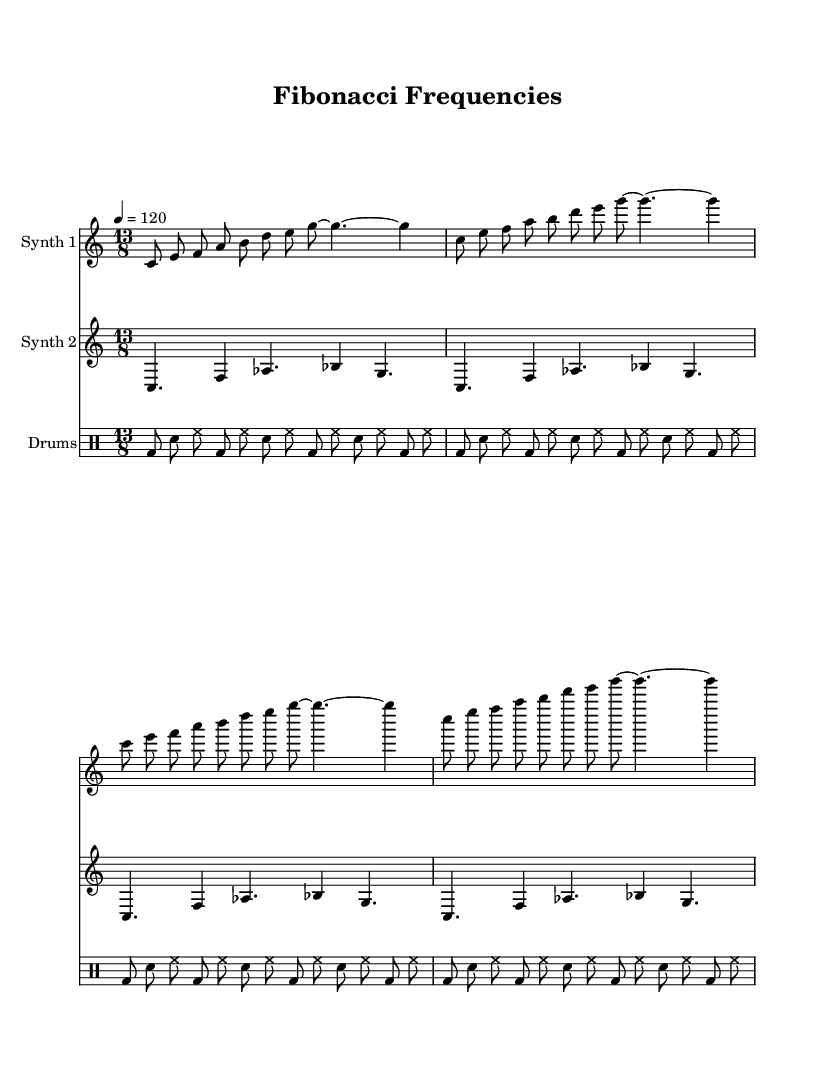What is the key signature of this music? The key signature is indicated at the beginning of the score, showing no sharps or flats, which corresponds to C major.
Answer: C major What is the time signature of this music? The time signature is present at the start of the piece, represented as 13/8, which means there are 13 eighth notes in each measure.
Answer: 13/8 What is the tempo marking of this composition? The tempo marking, found near the top of the sheet music, specifies '4 = 120', indicating the quarter note gets 120 beats per minute.
Answer: 120 How many measures are there in Synth 1? Synth 1 consists of a repeating pattern shown in four measures, and this is evident as the same musical phrase repeats throughout.
Answer: 4 Which algorithmic pattern is referenced in the title? The title "Fibonacci Frequencies" suggests that the composition is inspired by mathematical sequences, specifically the Fibonacci sequence.
Answer: Fibonacci How is the rhythm structured in the drum machine part? The rhythm in the drum machine part is structured in a consistent repeating pattern featuring bass drum and snare placements with hi-hat, notable for their steady pulse.
Answer: Steady pulse What does the synthesizer use to create melodies? The synthesizers utilize a blend of pitch intervals, specifically referring to the ascending and descending frequencies outlining the melody inspired by a mathematical framework.
Answer: Mathematical framework 